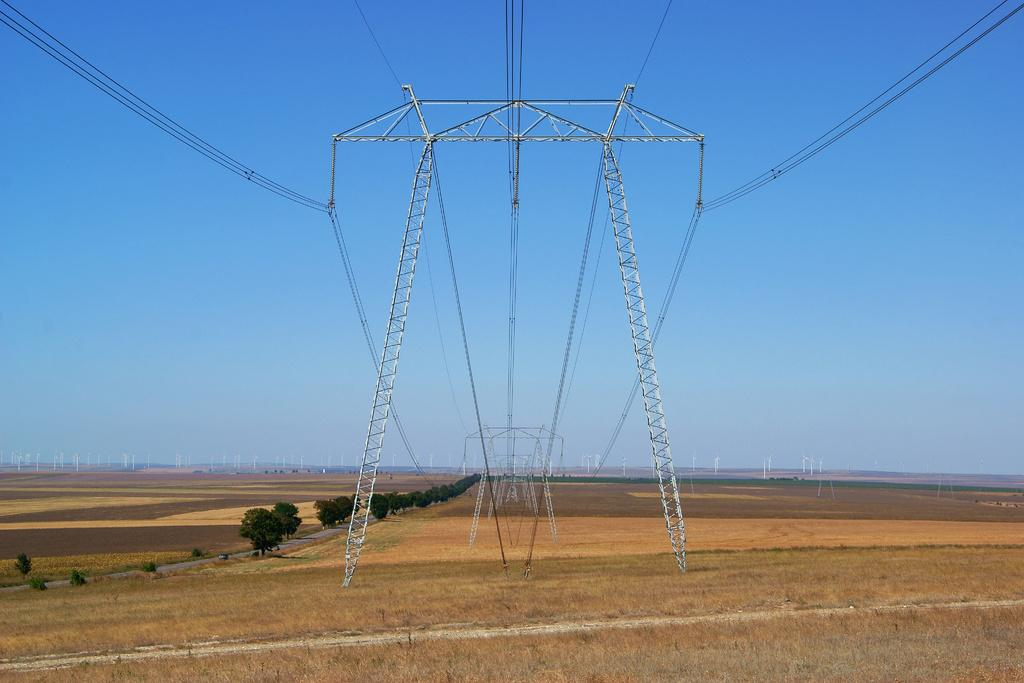What type of structures are present in the image? There are electric towers in the image. What is connected to the electric towers? Electric cables are connected to the electric towers. What type of vegetation can be seen in the image? There is grass and trees visible in the image. What is visible in the background of the image? Windmills are visible in the background of the image. What part of the natural environment is visible in the image? The sky is visible in the image. What type of reaction can be seen from the army in the image? There is no army present in the image, so no reaction can be observed. How does the grass wash itself in the image? Grass does not wash itself; it is a plant and does not have the ability to perform such actions. 